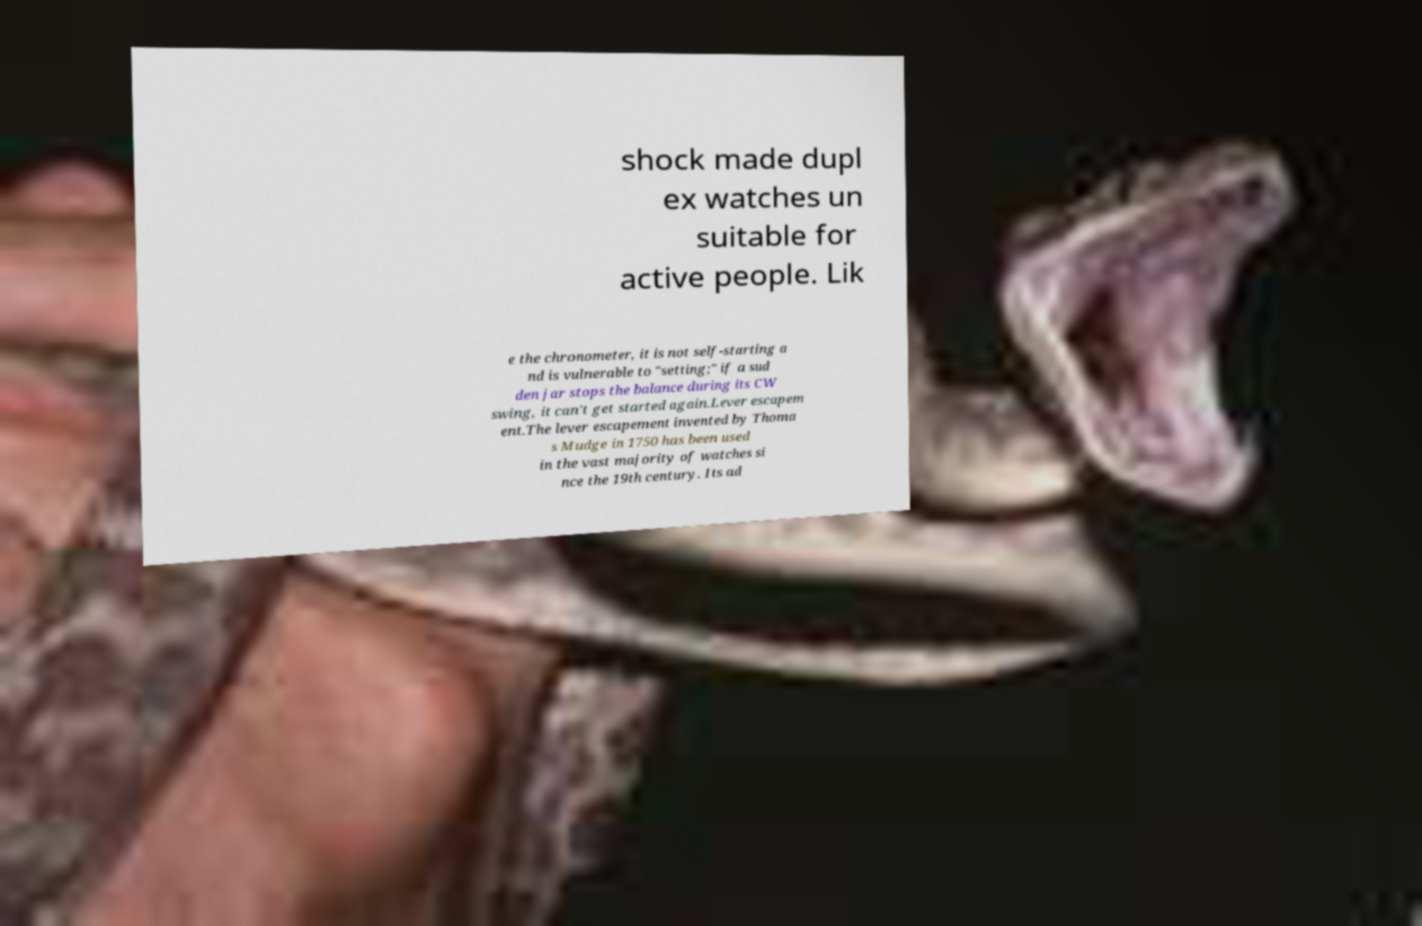Can you accurately transcribe the text from the provided image for me? shock made dupl ex watches un suitable for active people. Lik e the chronometer, it is not self-starting a nd is vulnerable to "setting;" if a sud den jar stops the balance during its CW swing, it can't get started again.Lever escapem ent.The lever escapement invented by Thoma s Mudge in 1750 has been used in the vast majority of watches si nce the 19th century. Its ad 